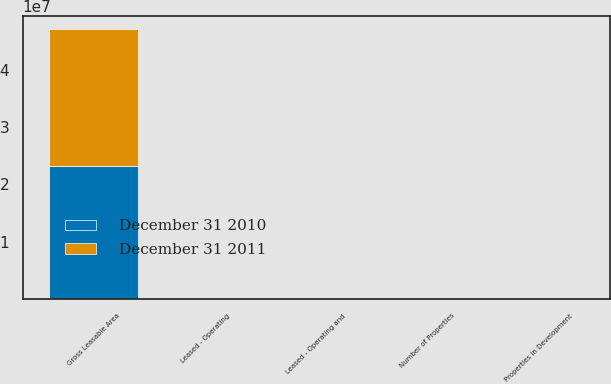Convert chart. <chart><loc_0><loc_0><loc_500><loc_500><stacked_bar_chart><ecel><fcel>Number of Properties<fcel>Properties in Development<fcel>Gross Leasable Area<fcel>Leased - Operating and<fcel>Leased - Operating<nl><fcel>December 31 2011<fcel>217<fcel>7<fcel>2.37501e+07<fcel>92.2<fcel>93.1<nl><fcel>December 31 2010<fcel>215<fcel>25<fcel>2.3267e+07<fcel>91.6<fcel>92.6<nl></chart> 